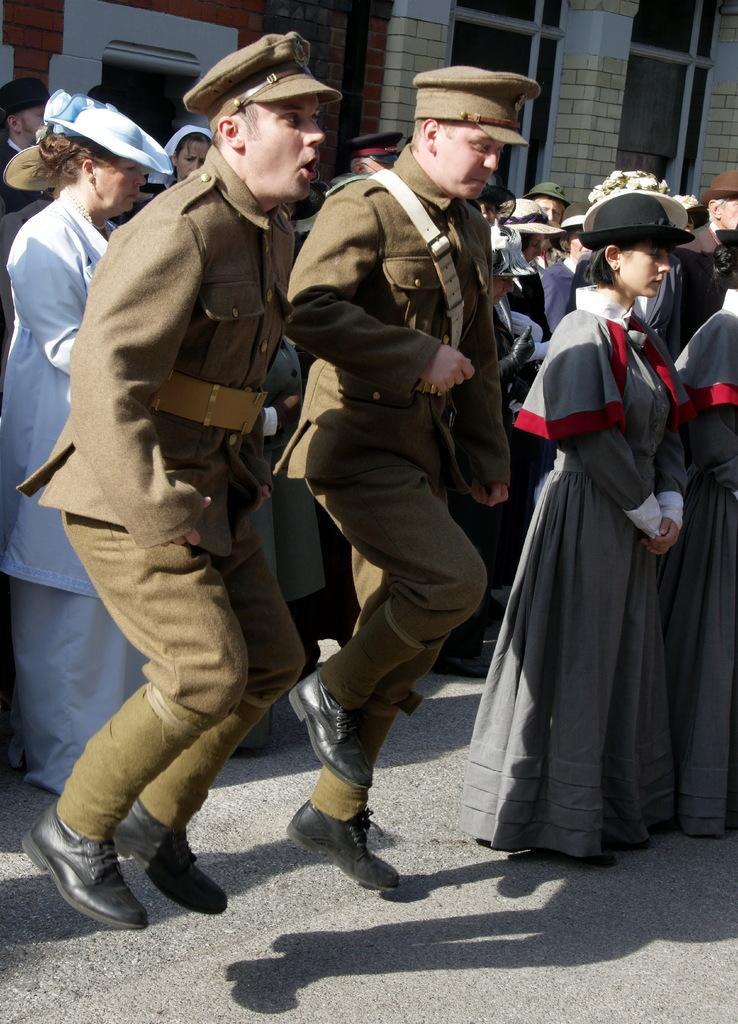Describe this image in one or two sentences. In the picture I can see group of people are standing among them men in the front are wearing hats and uniforms. In the background I can see buildings. 